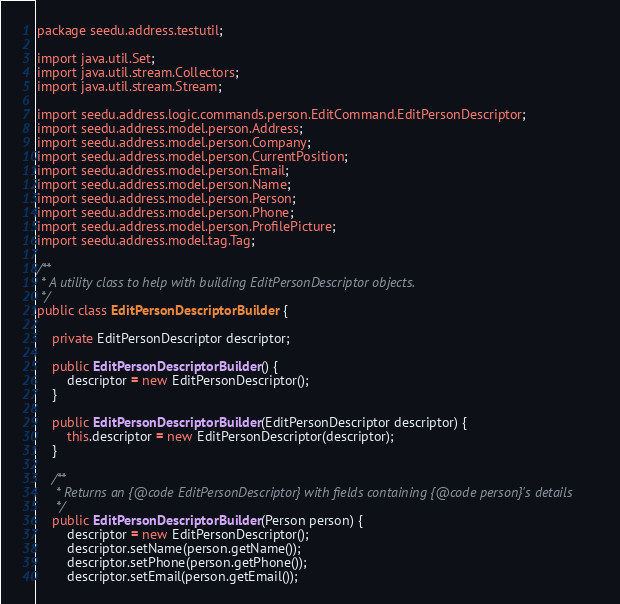<code> <loc_0><loc_0><loc_500><loc_500><_Java_>package seedu.address.testutil;

import java.util.Set;
import java.util.stream.Collectors;
import java.util.stream.Stream;

import seedu.address.logic.commands.person.EditCommand.EditPersonDescriptor;
import seedu.address.model.person.Address;
import seedu.address.model.person.Company;
import seedu.address.model.person.CurrentPosition;
import seedu.address.model.person.Email;
import seedu.address.model.person.Name;
import seedu.address.model.person.Person;
import seedu.address.model.person.Phone;
import seedu.address.model.person.ProfilePicture;
import seedu.address.model.tag.Tag;

/**
 * A utility class to help with building EditPersonDescriptor objects.
 */
public class EditPersonDescriptorBuilder {

    private EditPersonDescriptor descriptor;

    public EditPersonDescriptorBuilder() {
        descriptor = new EditPersonDescriptor();
    }

    public EditPersonDescriptorBuilder(EditPersonDescriptor descriptor) {
        this.descriptor = new EditPersonDescriptor(descriptor);
    }

    /**
     * Returns an {@code EditPersonDescriptor} with fields containing {@code person}'s details
     */
    public EditPersonDescriptorBuilder(Person person) {
        descriptor = new EditPersonDescriptor();
        descriptor.setName(person.getName());
        descriptor.setPhone(person.getPhone());
        descriptor.setEmail(person.getEmail());</code> 